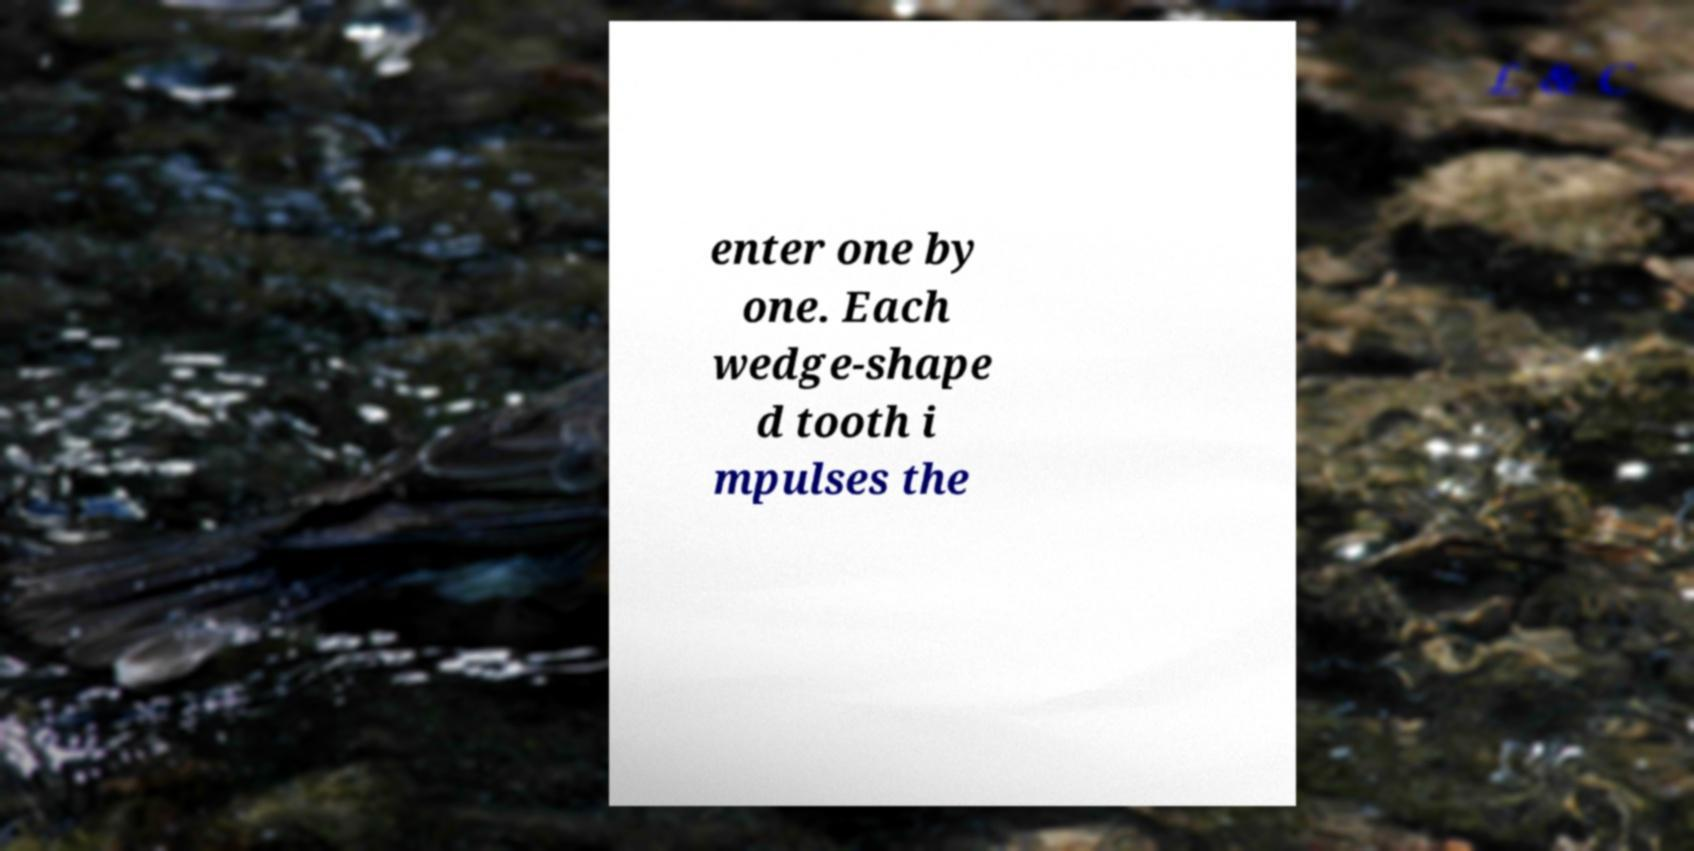Could you assist in decoding the text presented in this image and type it out clearly? enter one by one. Each wedge-shape d tooth i mpulses the 